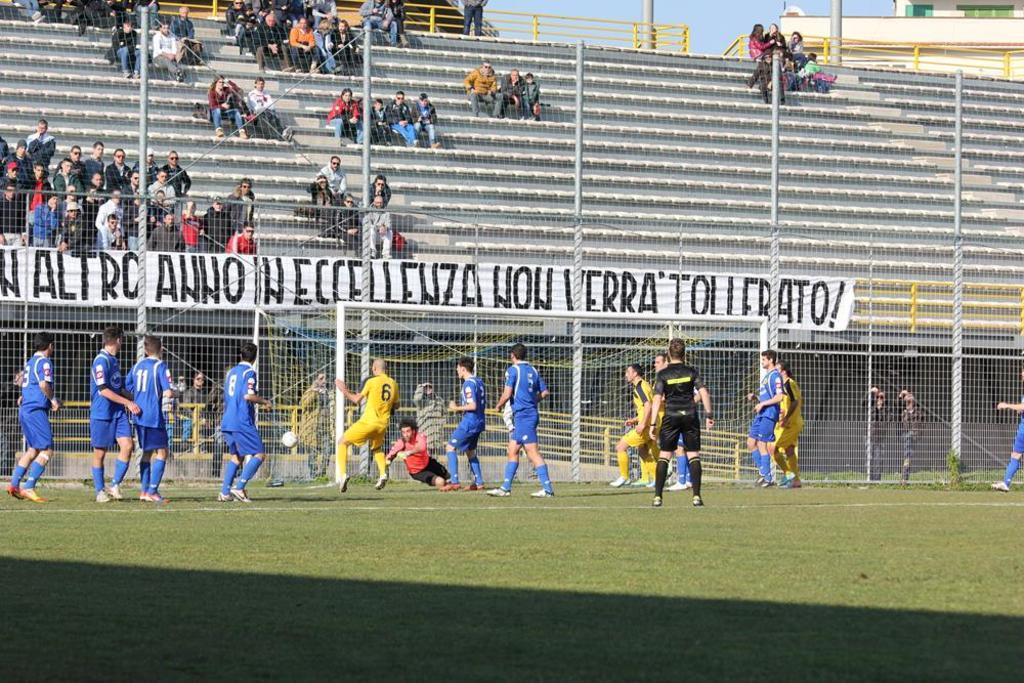What are the players in the image wearing? The players in the image are wearing different color dresses. What sport is being played in the image? Netball is being played in the image, as indicated by the presence of a netball. What is used to separate the playing area in the image? Net fencing is used to separate the playing area in the image. What can be seen hanging in the background of the image? There is a white banner in the image. Where are some people sitting in the image? There is a group of people sitting on the stairs in the image. What brand of toothpaste is being advertised on the desk in the image? There is no desk or toothpaste present in the image. What type of table is being used by the players in the image? There is no table mentioned or visible in the image. 